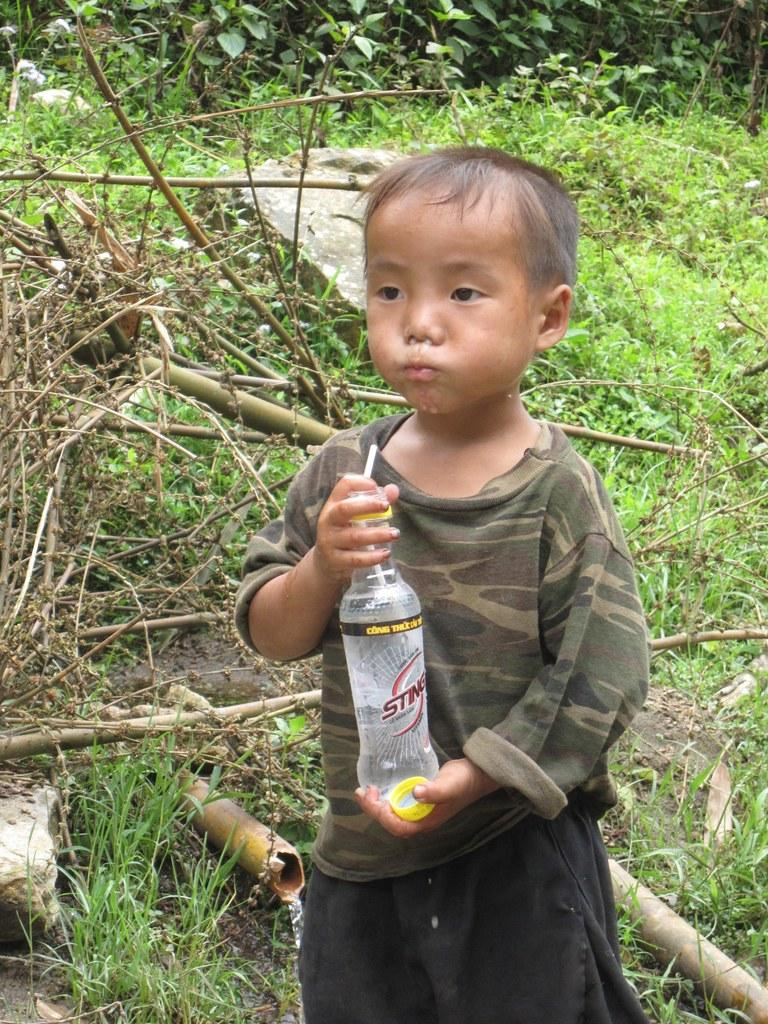What is the main subject of the picture? The main subject of the picture is a kid. What is the kid holding in his hand? The kid is holding a bottle in his hand. What is the kid doing with the bottle? The kid is drinking water from the bottle. What can be seen in the background of the picture? There are plants and trees in the background of the picture. Where is the station located in the image? There is no station present in the image. What type of division can be seen between the plants and trees in the image? There is no division between the plants and trees in the image; they are both visible in the background. 